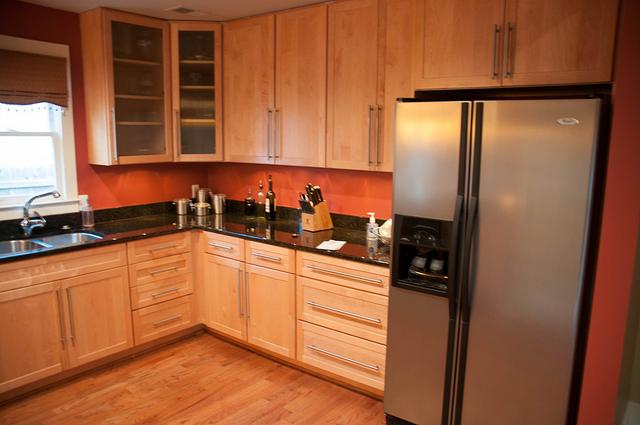What would someone store in the space below the sink?
Quick response, please. Anything they want. Is this a kitchen?
Concise answer only. Yes. Is there a note on the counter?
Be succinct. Yes. What color is the wall?
Keep it brief. Orange. 